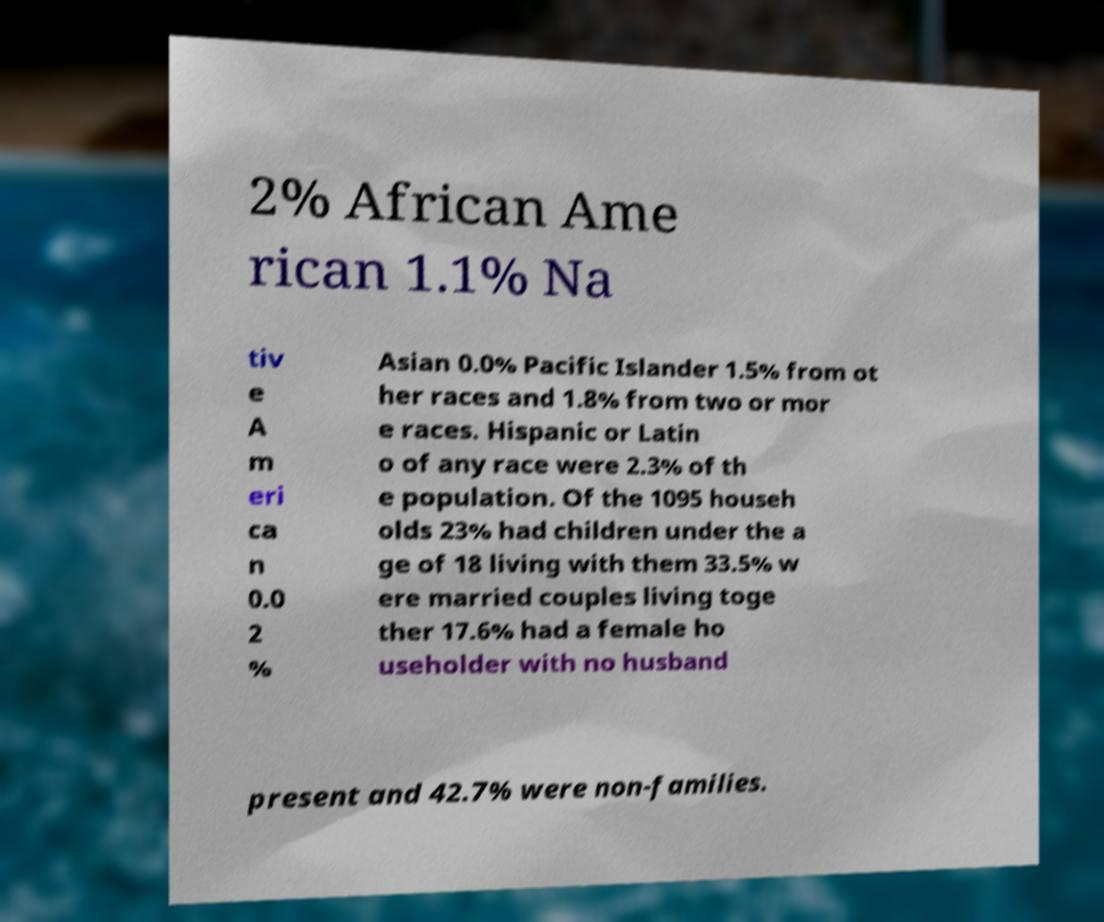Can you accurately transcribe the text from the provided image for me? 2% African Ame rican 1.1% Na tiv e A m eri ca n 0.0 2 % Asian 0.0% Pacific Islander 1.5% from ot her races and 1.8% from two or mor e races. Hispanic or Latin o of any race were 2.3% of th e population. Of the 1095 househ olds 23% had children under the a ge of 18 living with them 33.5% w ere married couples living toge ther 17.6% had a female ho useholder with no husband present and 42.7% were non-families. 